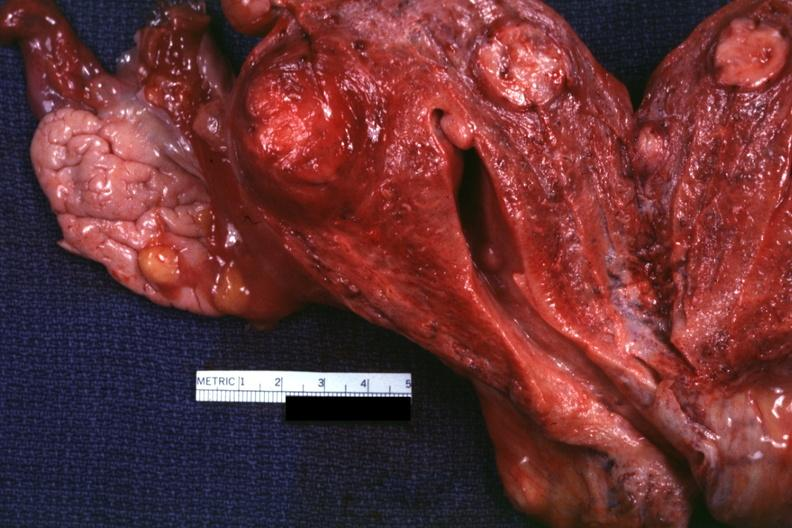does this image show cut surface of uterus several lesions?
Answer the question using a single word or phrase. Yes 